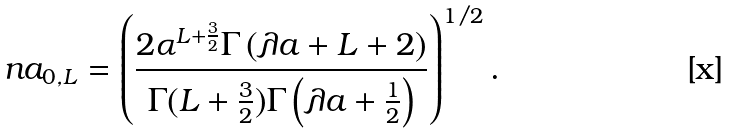<formula> <loc_0><loc_0><loc_500><loc_500>\ n a _ { 0 , L } = \left ( \frac { 2 \alpha ^ { L + \frac { 3 } { 2 } } \Gamma \left ( \lambda a + L + 2 \right ) } { \Gamma ( L + \frac { 3 } { 2 } ) \Gamma \left ( \lambda a + \frac { 1 } { 2 } \right ) } \right ) ^ { 1 / 2 } .</formula> 